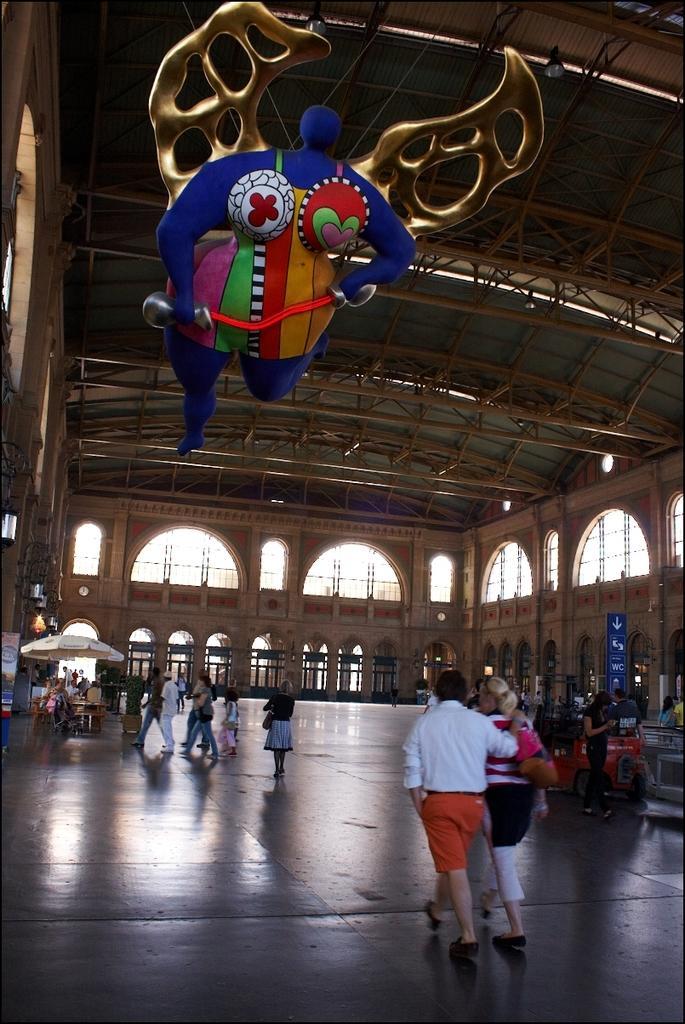Describe this image in one or two sentences. In this image I see the inside view of a building and I see the floor on which there are number of people and I see a thing over here which is hanged and I see the blue color board over here. 